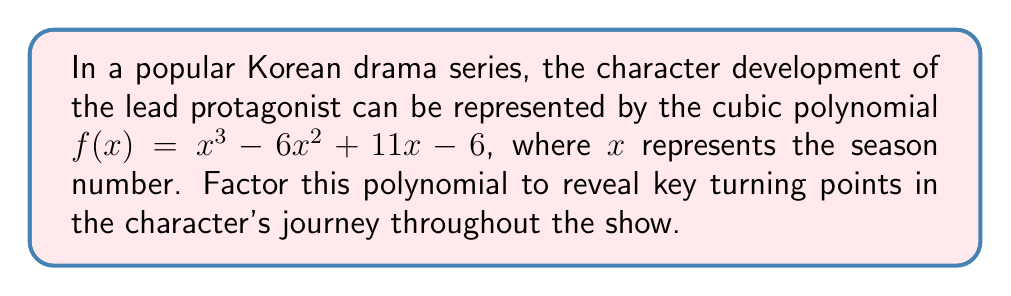Could you help me with this problem? Let's approach this step-by-step:

1) First, we'll try to find a factor by guessing a root. Since the constant term is -6, possible factors are ±1, ±2, ±3, ±6.

2) Let's try $x = 1$:
   $f(1) = 1^3 - 6(1)^2 + 11(1) - 6 = 1 - 6 + 11 - 6 = 0$

3) So, $(x - 1)$ is a factor. We can use polynomial long division to find the other factor:

   $$\begin{array}{r}
   x^2 - 5x + 6 \\
   x - 1 \enclose{longdiv}{x^3 - 6x^2 + 11x - 6} \\
   \underline{x^3 - x^2} \\
   -5x^2 + 11x \\
   \underline{-5x^2 + 5x} \\
   6x - 6 \\
   \underline{6x - 6} \\
   0
   \end{array}$$

4) So, $f(x) = (x - 1)(x^2 - 5x + 6)$

5) Now, we need to factor $x^2 - 5x + 6$. We can do this by finding two numbers that multiply to give 6 and add to give -5. These numbers are -2 and -3.

6) Therefore, $x^2 - 5x + 6 = (x - 2)(x - 3)$

7) Putting it all together, we get:
   $f(x) = (x - 1)(x - 2)(x - 3)$

This factorization reveals that the character experiences significant developments or turning points in seasons 1, 2, and 3 of the show.
Answer: $f(x) = (x - 1)(x - 2)(x - 3)$ 